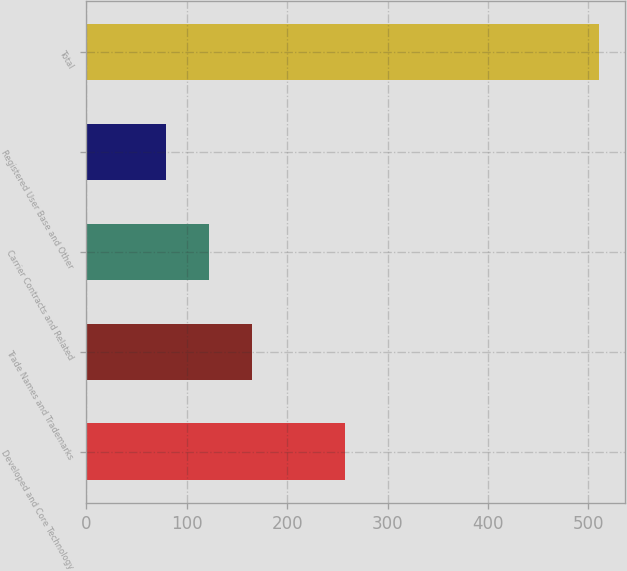Convert chart to OTSL. <chart><loc_0><loc_0><loc_500><loc_500><bar_chart><fcel>Developed and Core Technology<fcel>Trade Names and Trademarks<fcel>Carrier Contracts and Related<fcel>Registered User Base and Other<fcel>Total<nl><fcel>258<fcel>165.4<fcel>122.2<fcel>79<fcel>511<nl></chart> 